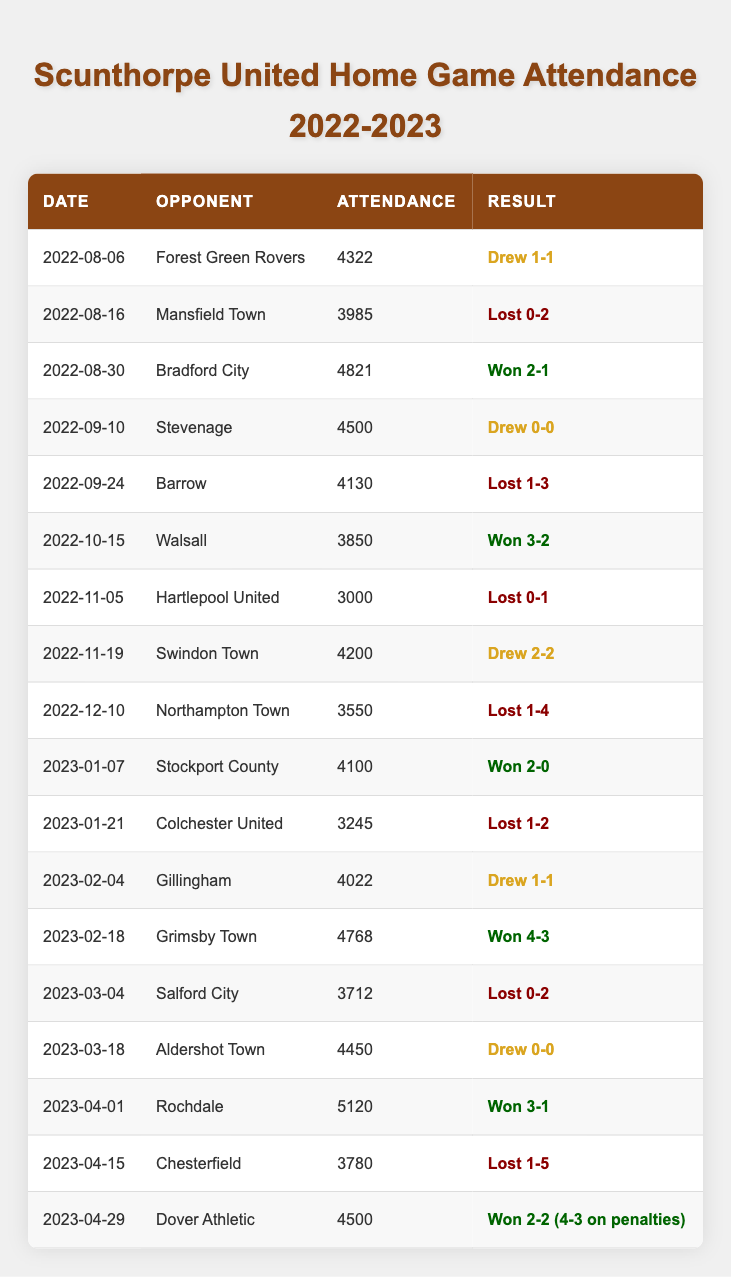What was the attendance for the match against Bradford City? Referring to the table, the attendance figure listed for the match against Bradford City on 2022-08-30 is 4821.
Answer: 4821 Which match had the highest attendance? By inspecting the attendance figures in the table, the match against Rochdale on 2023-04-01 had the highest attendance at 5120.
Answer: 5120 Was there a match where Scunthorpe United lost with an attendance of less than 4000? In the table, the match against Hartlepool United on 2022-11-05 shows a loss with an attendance of 3000. Thus, the statement is true.
Answer: Yes How many matches did Scunthorpe United win at home? Summing up the winning results from the table, I find matches against Bradford City, Walsall, Stockport County, Grimsby Town, Rochdale, and Dover Athletic, yielding a total of 6 wins.
Answer: 6 What was the total attendance for all home matches? To compute the total attendance, I must add all individual attendance values listed in the table: 4322 + 3985 + 4821 + 4500 + 4130 + 3850 + 3000 + 4200 + 3550 + 4100 + 3245 + 4022 + 4768 + 3712 + 4450 + 5120 + 3780 + 4500 = 70343.
Answer: 70343 Did Scunthorpe United ever draw a match with more than 4000 attendees? The table shows several draws; specifically, against Forest Green Rovers (4322), Stevenage (4500), Swindon Town (4200), Gillingham (4022), and Aldershot Town (4450), confirming that it’s true.
Answer: Yes What was the average attendance for home games when Scunthorpe United won? First, I identify the matches won: Bradford City, Walsall, Stockport County, Grimsby Town, Rochdale, and Dover Athletic, with the respective attendances of 4821, 3850, 4100, 4768, 5120, and 4500. Totaling these yields 25709 across 6 matches, thus the average is 25709 / 6, which equals approximately 4284.83.
Answer: 4285 Against which opponent did Scunthorpe United face their lowest attendance and what was it? The lowest recorded attendance in the table occurred during the match against Hartlepool United on 2022-11-05, with an attendance of 3000.
Answer: Hartlepool United, 3000 How many home matches ended in a draw? In the table, I find the matches that ended in a draw against Forest Green Rovers, Stevenage, Swindon Town, Gillingham, and Aldershot Town, totaling 5 drawn matches.
Answer: 5 